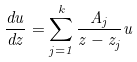<formula> <loc_0><loc_0><loc_500><loc_500>\frac { d u } { d z } = \sum _ { j = 1 } ^ { k } \frac { A _ { j } } { z - z _ { j } } u</formula> 